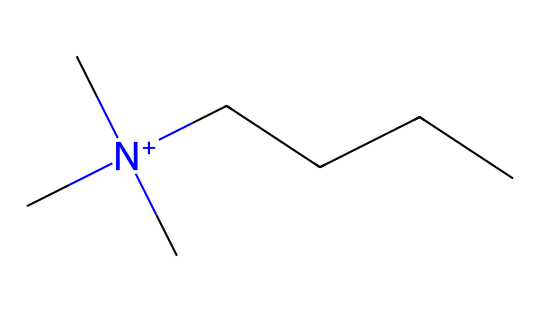How many carbon atoms are in this compound? The SMILES representation indicates a total of five carbon atoms from the "C" symbols before the "CCCC", which denotes an additional four carbon atoms in a straight-chain, resulting in five in total.
Answer: five What type of nitrogen is present in this compound? The notation "[N+]" indicates that the nitrogen atom carries a positive charge, classifying it as a quaternary ammonium ion.
Answer: quaternary ammonium How many hydrogens are associated with the nitrogen atom? Each of the three methyl groups connected to the nitrogen contributes three hydrogens (3 x 3 = 9), and the nitrogen's positive charge suggests that it accommodates four total substituents. Therefore, there are no additional hydrogens attached, leading to a net contribution of 9 hydrogens.
Answer: nine What is the overall charge of this molecule? The presence of a positively charged nitrogen atom and no other charged components gives the entire molecule a +1 charge.
Answer: +1 Which functional group is dominant in this compound? The nitrogen atom in a quaternary structure is central to the molecule, while the long carbon chain is a hydrocarbon tail; thus, the quaternary ammonium ion acts as the functional group here.
Answer: quaternary ammonium ion How does this compound compare to typical organic solvents in terms of polarity? The presence of a quaternary ammonium group increases the overall polarity of the molecule compared to non-polar organic solvents, primarily due to the positive charge on nitrogen, which attracts polar solvents.
Answer: more polar 